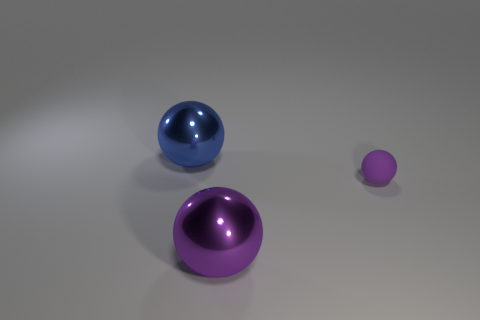Is there any other thing that has the same size as the purple rubber sphere?
Give a very brief answer. No. Is there any other thing that is the same material as the small purple ball?
Offer a terse response. No. How big is the purple object that is in front of the tiny purple rubber thing?
Provide a short and direct response. Large. Are there fewer blue balls right of the rubber object than small purple matte balls to the left of the big blue thing?
Offer a terse response. No. What material is the sphere that is behind the big purple metallic object and left of the small matte object?
Provide a short and direct response. Metal. How many blue objects are either matte balls or large shiny spheres?
Your answer should be compact. 1. Are there any purple things to the right of the small purple matte ball?
Ensure brevity in your answer.  No. The purple metallic ball has what size?
Make the answer very short. Large. There is a purple shiny thing that is the same shape as the blue metal object; what size is it?
Offer a terse response. Large. What number of purple matte things are left of the purple thing that is left of the rubber ball?
Offer a terse response. 0. 